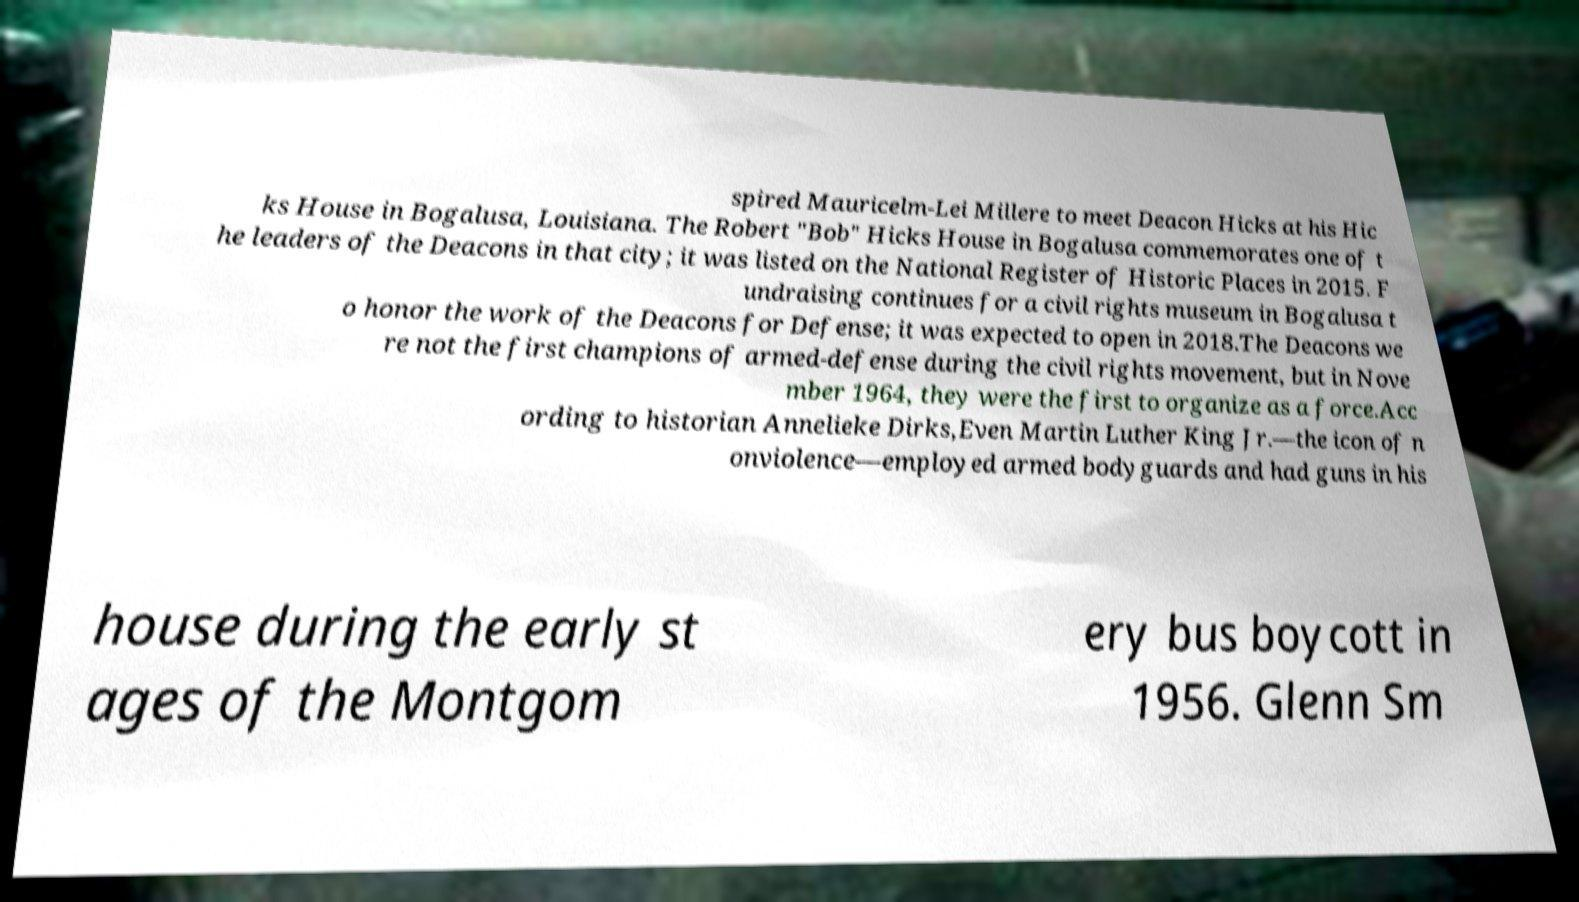Please read and relay the text visible in this image. What does it say? spired Mauricelm-Lei Millere to meet Deacon Hicks at his Hic ks House in Bogalusa, Louisiana. The Robert "Bob" Hicks House in Bogalusa commemorates one of t he leaders of the Deacons in that city; it was listed on the National Register of Historic Places in 2015. F undraising continues for a civil rights museum in Bogalusa t o honor the work of the Deacons for Defense; it was expected to open in 2018.The Deacons we re not the first champions of armed-defense during the civil rights movement, but in Nove mber 1964, they were the first to organize as a force.Acc ording to historian Annelieke Dirks,Even Martin Luther King Jr.—the icon of n onviolence—employed armed bodyguards and had guns in his house during the early st ages of the Montgom ery bus boycott in 1956. Glenn Sm 